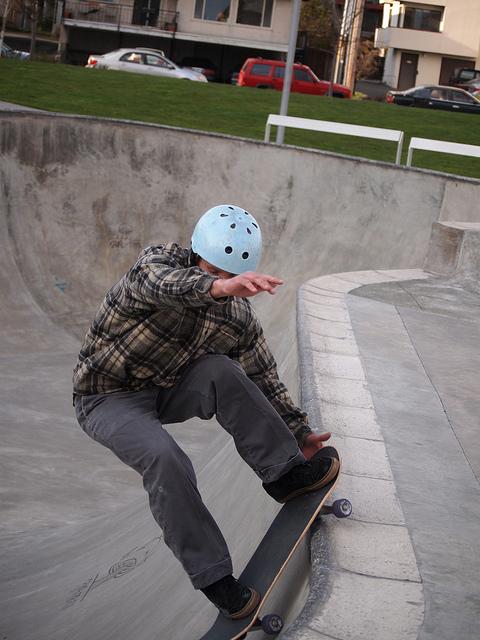What are the cars doing in the background?
Be succinct. Parked. Is the skater falling down?
Be succinct. No. Is the skater doing a trick?
Answer briefly. Yes. 